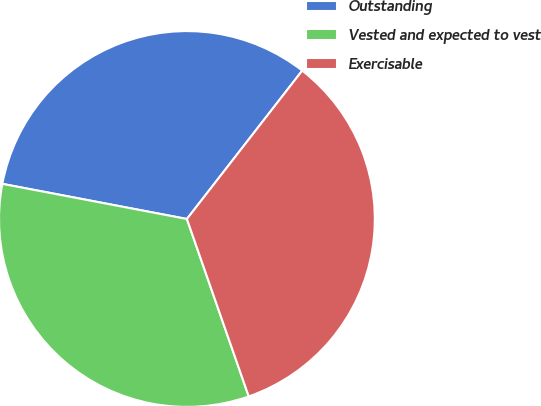Convert chart to OTSL. <chart><loc_0><loc_0><loc_500><loc_500><pie_chart><fcel>Outstanding<fcel>Vested and expected to vest<fcel>Exercisable<nl><fcel>32.52%<fcel>33.33%<fcel>34.15%<nl></chart> 